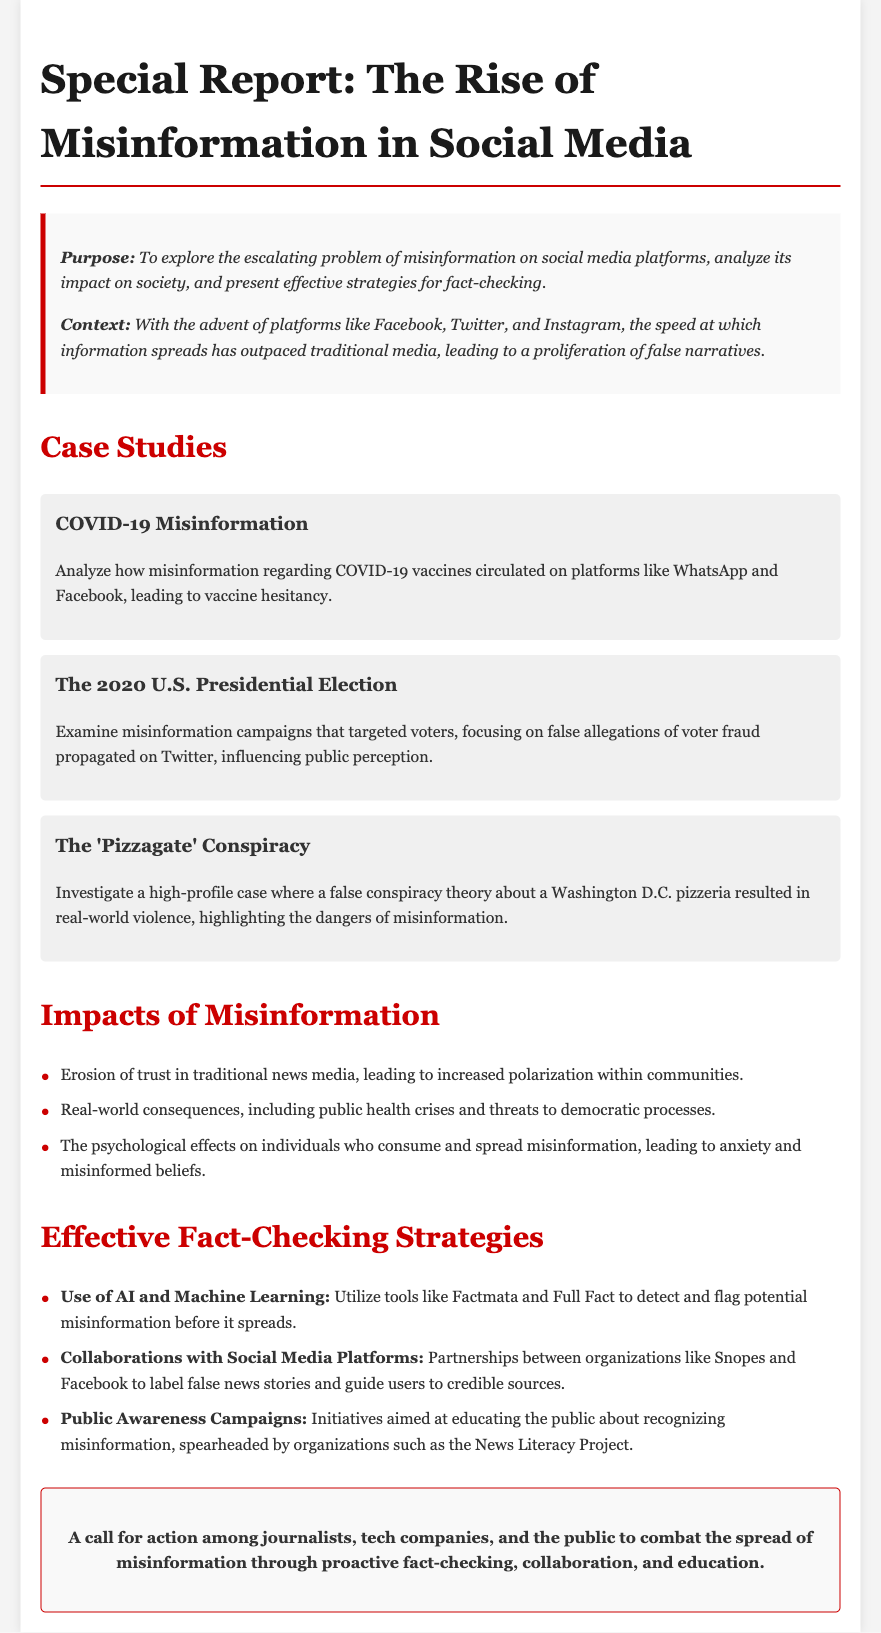What is the purpose of the report? The purpose of the report is to explore the escalating problem of misinformation on social media platforms, analyze its impact on society, and present effective strategies for fact-checking.
Answer: To explore the escalating problem of misinformation on social media, analyze its impact on society, and present effective strategies for fact-checking How many case studies are presented? The report lists three specific case studies that illustrate the issue of misinformation.
Answer: Three What is one of the impacts of misinformation mentioned in the report? The report outlines several impacts, one being the erosion of trust in traditional news media.
Answer: Erosion of trust in traditional news media Which social media platform was mentioned in the context of COVID-19 misinformation? The report specifies WhatsApp and Facebook as platforms where COVID-19 vaccine misinformation circulated.
Answer: WhatsApp and Facebook What is one strategy for effective fact-checking? The report lists several strategies, including the use of AI and machine learning tools like Factmata.
Answer: Use of AI and Machine Learning What high-profile conspiracy theory does the report discuss? The 'Pizzagate' conspiracy is highlighted as a significant example of misinformation that led to real-world consequences.
Answer: The 'Pizzagate' Conspiracy What type of campaigns does the report suggest to combat misinformation? The report recommends public awareness campaigns to educate individuals about recognizing misinformation.
Answer: Public Awareness Campaigns What is emphasized in the conclusion of the report? The conclusion calls for action among journalists, tech companies, and the public to combat misinformation.
Answer: A call for action among journalists, tech companies, and the public 